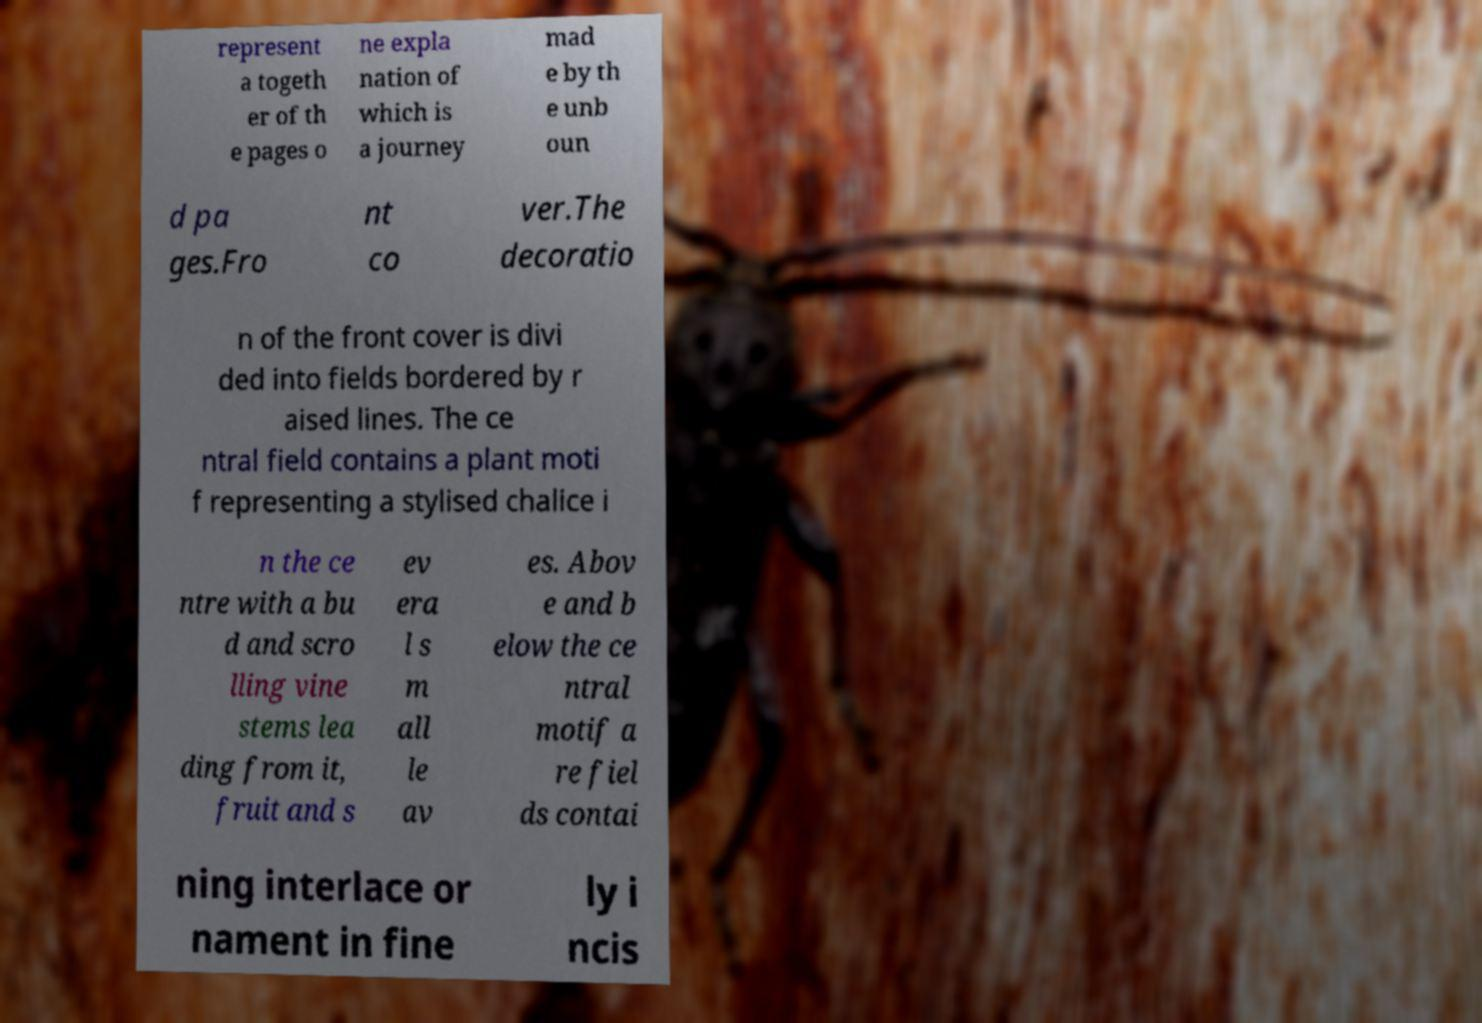Can you read and provide the text displayed in the image?This photo seems to have some interesting text. Can you extract and type it out for me? represent a togeth er of th e pages o ne expla nation of which is a journey mad e by th e unb oun d pa ges.Fro nt co ver.The decoratio n of the front cover is divi ded into fields bordered by r aised lines. The ce ntral field contains a plant moti f representing a stylised chalice i n the ce ntre with a bu d and scro lling vine stems lea ding from it, fruit and s ev era l s m all le av es. Abov e and b elow the ce ntral motif a re fiel ds contai ning interlace or nament in fine ly i ncis 